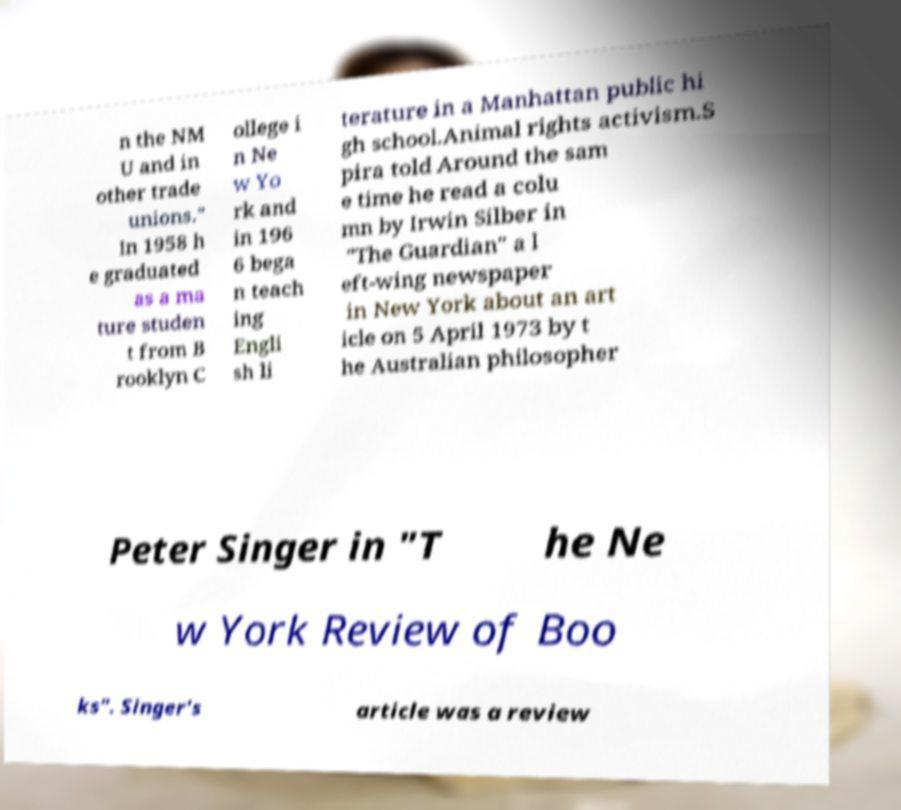What messages or text are displayed in this image? I need them in a readable, typed format. n the NM U and in other trade unions." In 1958 h e graduated as a ma ture studen t from B rooklyn C ollege i n Ne w Yo rk and in 196 6 bega n teach ing Engli sh li terature in a Manhattan public hi gh school.Animal rights activism.S pira told Around the sam e time he read a colu mn by Irwin Silber in "The Guardian" a l eft-wing newspaper in New York about an art icle on 5 April 1973 by t he Australian philosopher Peter Singer in "T he Ne w York Review of Boo ks". Singer's article was a review 